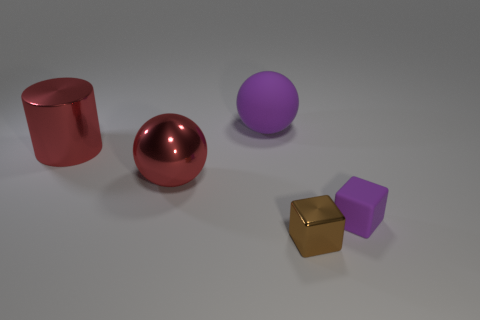Add 4 red cubes. How many objects exist? 9 Subtract all spheres. How many objects are left? 3 Subtract all big purple matte balls. Subtract all tiny blue matte objects. How many objects are left? 4 Add 1 big red metallic cylinders. How many big red metallic cylinders are left? 2 Add 4 yellow matte things. How many yellow matte things exist? 4 Subtract 1 red cylinders. How many objects are left? 4 